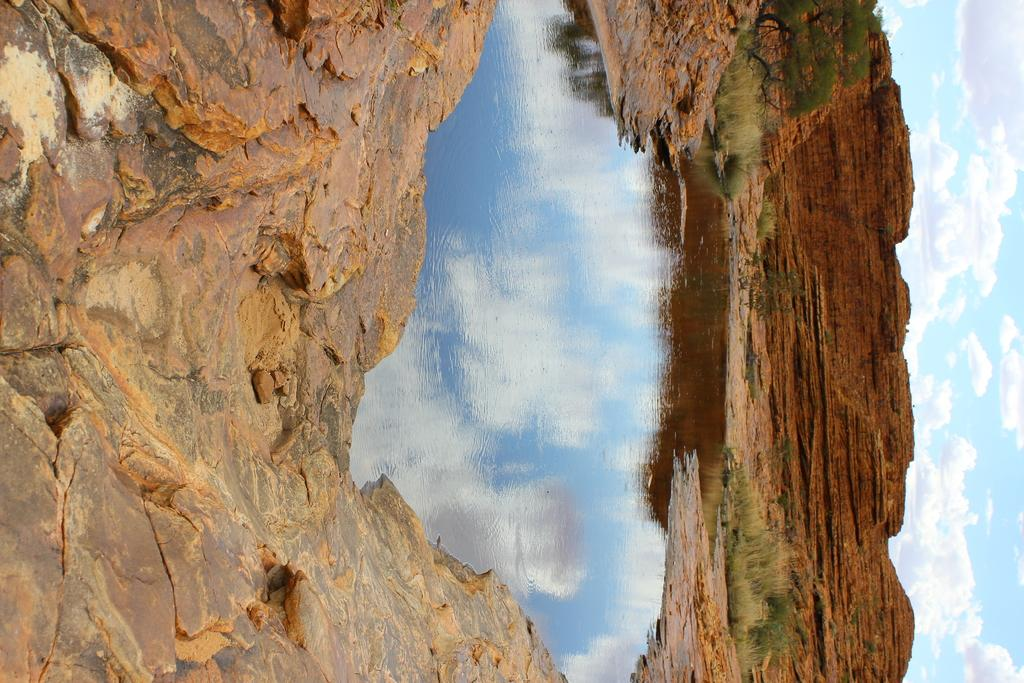What is located in the foreground of the image? There is a pond and a mountain surface in the foreground of the image. What can be seen in the background of the image? There are mountains and the sky visible in the background of the image. How many icicles are hanging from the mountain surface in the image? There are no icicles present in the image. What is the mountain surface being used for in the image? The mountain surface is not being used for anything in the image; it is simply a part of the landscape. 